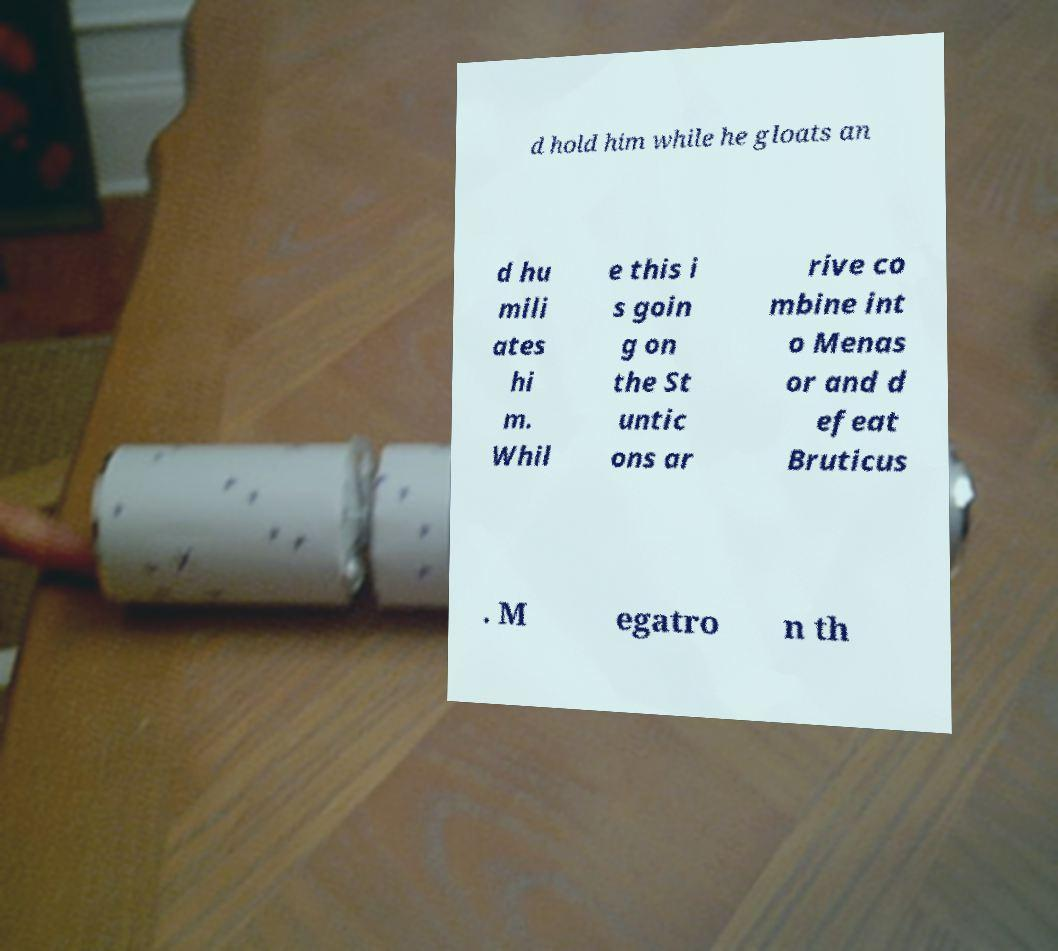Can you accurately transcribe the text from the provided image for me? d hold him while he gloats an d hu mili ates hi m. Whil e this i s goin g on the St untic ons ar rive co mbine int o Menas or and d efeat Bruticus . M egatro n th 